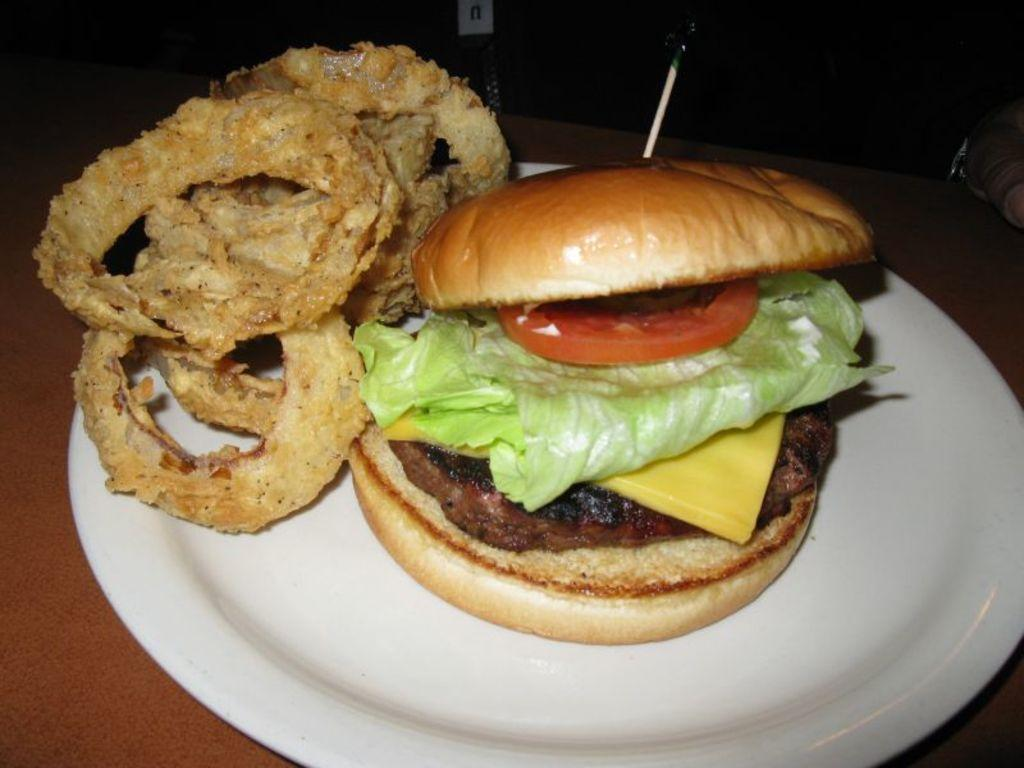What object is present on the plate in the image? There are food items on the plate in the image. What is the color of the plate? The plate is white in color. What can be seen in the background of the image? The background of the image is dark. How many potatoes can be seen on the plate in the image? There is no information about potatoes in the image, so we cannot determine their presence or quantity. 